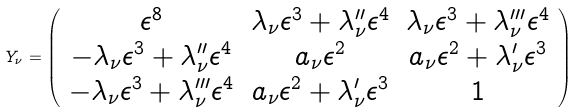Convert formula to latex. <formula><loc_0><loc_0><loc_500><loc_500>Y _ { \nu } = \left ( \begin{array} { c c c } \epsilon ^ { 8 } & \lambda _ { \nu } \epsilon ^ { 3 } + \lambda _ { \nu } ^ { \prime \prime } \epsilon ^ { 4 } & \lambda _ { \nu } \epsilon ^ { 3 } + \lambda _ { \nu } ^ { \prime \prime \prime } \epsilon ^ { 4 } \\ - \lambda _ { \nu } \epsilon ^ { 3 } + \lambda _ { \nu } ^ { \prime \prime } \epsilon ^ { 4 } & a _ { \nu } \epsilon ^ { 2 } & a _ { \nu } \epsilon ^ { 2 } + \lambda _ { \nu } ^ { \prime } \epsilon ^ { 3 } \\ - \lambda _ { \nu } \epsilon ^ { 3 } + \lambda _ { \nu } ^ { \prime \prime \prime } \epsilon ^ { 4 } & a _ { \nu } \epsilon ^ { 2 } + \lambda _ { \nu } ^ { \prime } \epsilon ^ { 3 } & 1 \end{array} \right )</formula> 